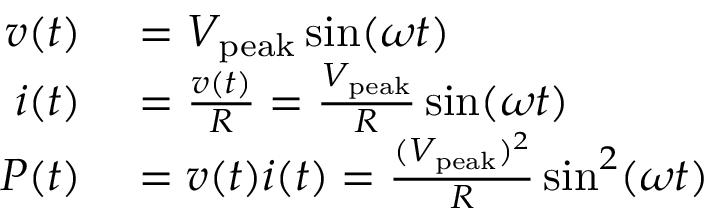Convert formula to latex. <formula><loc_0><loc_0><loc_500><loc_500>\begin{array} { r l } { v ( t ) } & = V _ { p e a k } \sin ( \omega t ) } \\ { i ( t ) } & = { \frac { v ( t ) } { R } } = { \frac { V _ { p e a k } } { R } } \sin ( \omega t ) } \\ { P ( t ) } & = v ( t ) i ( t ) = { \frac { ( V _ { p e a k } ) ^ { 2 } } { R } } \sin ^ { 2 } ( \omega t ) } \end{array}</formula> 